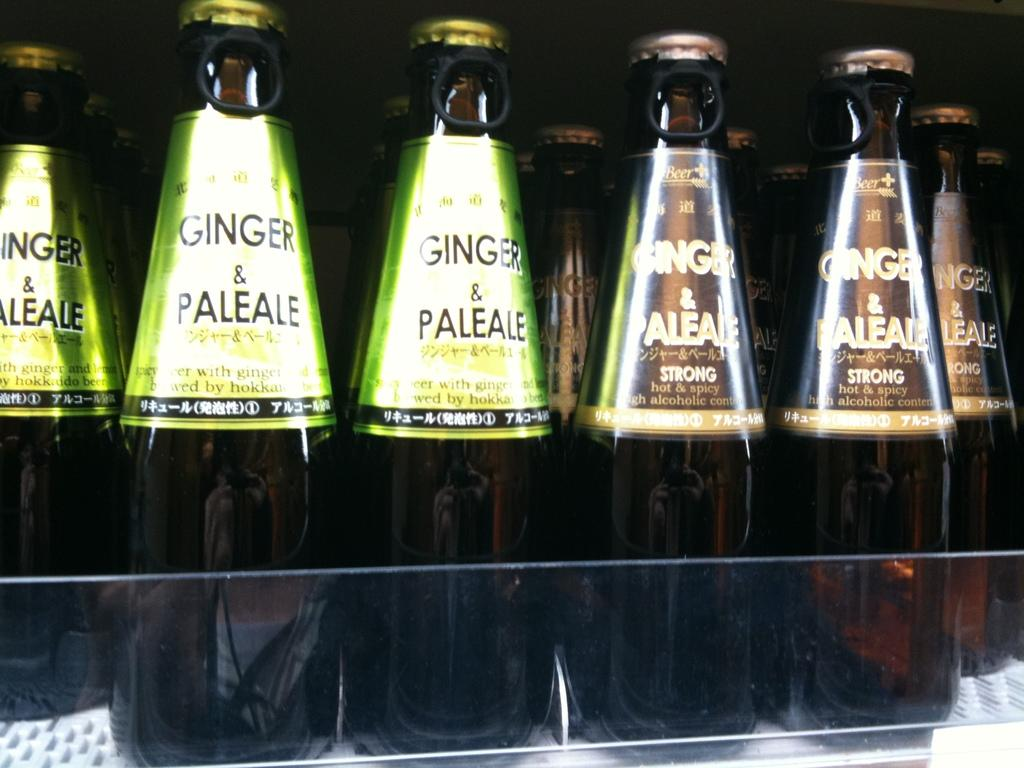<image>
Summarize the visual content of the image. Bottles next to one another and says "Ginger & Paleale" on the label. 